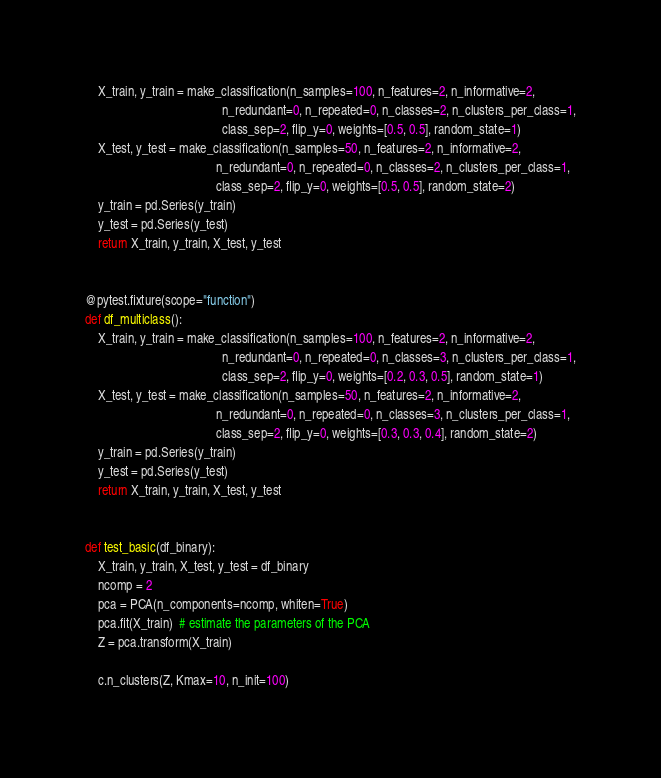Convert code to text. <code><loc_0><loc_0><loc_500><loc_500><_Python_>    X_train, y_train = make_classification(n_samples=100, n_features=2, n_informative=2,
                                           n_redundant=0, n_repeated=0, n_classes=2, n_clusters_per_class=1,
                                           class_sep=2, flip_y=0, weights=[0.5, 0.5], random_state=1)
    X_test, y_test = make_classification(n_samples=50, n_features=2, n_informative=2,
                                         n_redundant=0, n_repeated=0, n_classes=2, n_clusters_per_class=1,
                                         class_sep=2, flip_y=0, weights=[0.5, 0.5], random_state=2)
    y_train = pd.Series(y_train)
    y_test = pd.Series(y_test)
    return X_train, y_train, X_test, y_test


@pytest.fixture(scope="function")
def df_multiclass():
    X_train, y_train = make_classification(n_samples=100, n_features=2, n_informative=2,
                                           n_redundant=0, n_repeated=0, n_classes=3, n_clusters_per_class=1,
                                           class_sep=2, flip_y=0, weights=[0.2, 0.3, 0.5], random_state=1)
    X_test, y_test = make_classification(n_samples=50, n_features=2, n_informative=2,
                                         n_redundant=0, n_repeated=0, n_classes=3, n_clusters_per_class=1,
                                         class_sep=2, flip_y=0, weights=[0.3, 0.3, 0.4], random_state=2)
    y_train = pd.Series(y_train)
    y_test = pd.Series(y_test)
    return X_train, y_train, X_test, y_test


def test_basic(df_binary):
    X_train, y_train, X_test, y_test = df_binary
    ncomp = 2
    pca = PCA(n_components=ncomp, whiten=True)
    pca.fit(X_train)  # estimate the parameters of the PCA
    Z = pca.transform(X_train)

    c.n_clusters(Z, Kmax=10, n_init=100)




</code> 